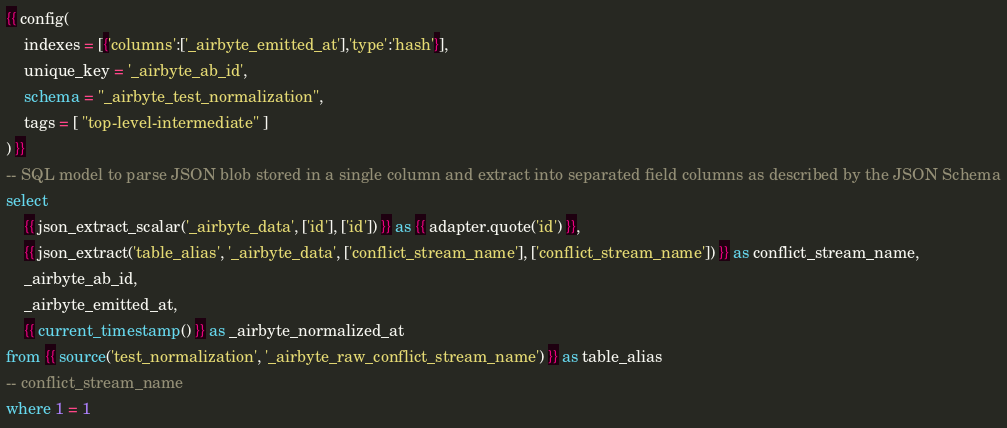<code> <loc_0><loc_0><loc_500><loc_500><_SQL_>{{ config(
    indexes = [{'columns':['_airbyte_emitted_at'],'type':'hash'}],
    unique_key = '_airbyte_ab_id',
    schema = "_airbyte_test_normalization",
    tags = [ "top-level-intermediate" ]
) }}
-- SQL model to parse JSON blob stored in a single column and extract into separated field columns as described by the JSON Schema
select
    {{ json_extract_scalar('_airbyte_data', ['id'], ['id']) }} as {{ adapter.quote('id') }},
    {{ json_extract('table_alias', '_airbyte_data', ['conflict_stream_name'], ['conflict_stream_name']) }} as conflict_stream_name,
    _airbyte_ab_id,
    _airbyte_emitted_at,
    {{ current_timestamp() }} as _airbyte_normalized_at
from {{ source('test_normalization', '_airbyte_raw_conflict_stream_name') }} as table_alias
-- conflict_stream_name
where 1 = 1

</code> 